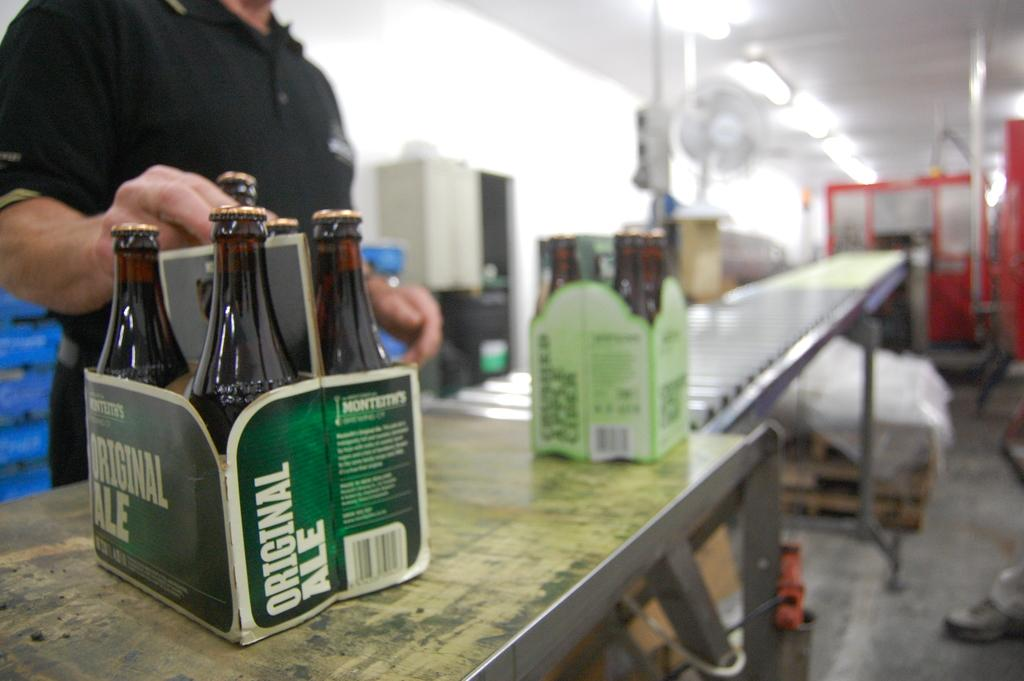<image>
Render a clear and concise summary of the photo. A 6-pack of original ale is sitting on the counter in a green box. 